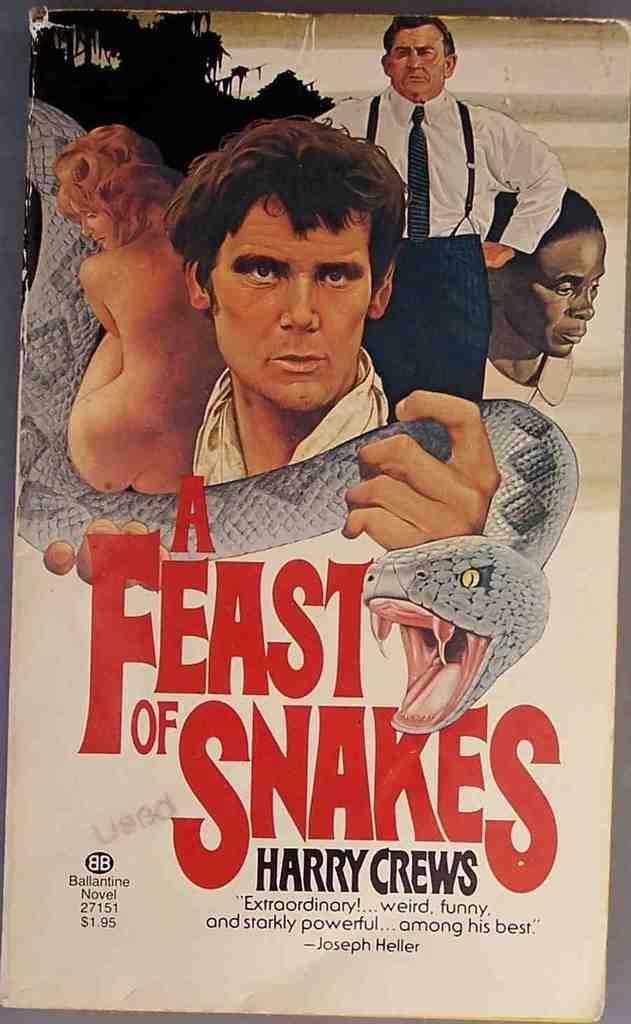<image>
Share a concise interpretation of the image provided. The cover of a feast of snakes written by harry crews. 